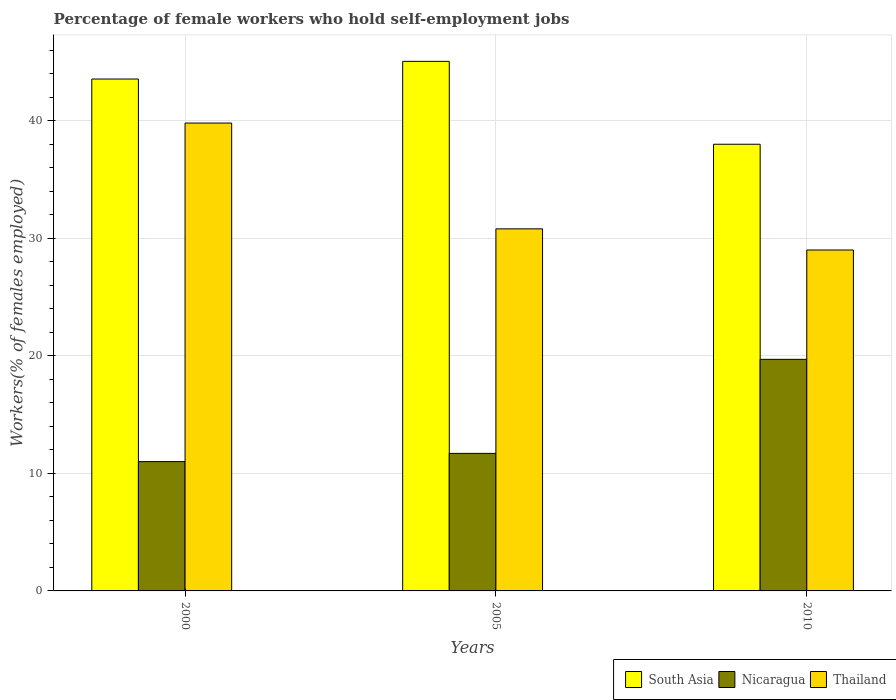How many bars are there on the 1st tick from the left?
Make the answer very short. 3. In how many cases, is the number of bars for a given year not equal to the number of legend labels?
Your answer should be very brief. 0. What is the percentage of self-employed female workers in Nicaragua in 2000?
Provide a succinct answer. 11. Across all years, what is the maximum percentage of self-employed female workers in Nicaragua?
Offer a very short reply. 19.7. Across all years, what is the minimum percentage of self-employed female workers in South Asia?
Provide a succinct answer. 38. In which year was the percentage of self-employed female workers in Nicaragua minimum?
Offer a very short reply. 2000. What is the total percentage of self-employed female workers in Nicaragua in the graph?
Offer a terse response. 42.4. What is the difference between the percentage of self-employed female workers in Nicaragua in 2000 and that in 2010?
Give a very brief answer. -8.7. What is the difference between the percentage of self-employed female workers in Nicaragua in 2010 and the percentage of self-employed female workers in South Asia in 2005?
Offer a very short reply. -25.35. What is the average percentage of self-employed female workers in South Asia per year?
Offer a very short reply. 42.2. In the year 2005, what is the difference between the percentage of self-employed female workers in South Asia and percentage of self-employed female workers in Nicaragua?
Your answer should be compact. 33.35. In how many years, is the percentage of self-employed female workers in Thailand greater than 28 %?
Offer a very short reply. 3. What is the ratio of the percentage of self-employed female workers in Thailand in 2005 to that in 2010?
Ensure brevity in your answer.  1.06. Is the percentage of self-employed female workers in South Asia in 2000 less than that in 2005?
Your answer should be very brief. Yes. What is the difference between the highest and the second highest percentage of self-employed female workers in South Asia?
Keep it short and to the point. 1.5. What is the difference between the highest and the lowest percentage of self-employed female workers in Thailand?
Offer a very short reply. 10.8. In how many years, is the percentage of self-employed female workers in Nicaragua greater than the average percentage of self-employed female workers in Nicaragua taken over all years?
Keep it short and to the point. 1. Is the sum of the percentage of self-employed female workers in Thailand in 2000 and 2010 greater than the maximum percentage of self-employed female workers in South Asia across all years?
Make the answer very short. Yes. What does the 1st bar from the left in 2005 represents?
Ensure brevity in your answer.  South Asia. What does the 3rd bar from the right in 2000 represents?
Your answer should be compact. South Asia. Is it the case that in every year, the sum of the percentage of self-employed female workers in South Asia and percentage of self-employed female workers in Thailand is greater than the percentage of self-employed female workers in Nicaragua?
Make the answer very short. Yes. How many bars are there?
Your answer should be compact. 9. How many years are there in the graph?
Your answer should be very brief. 3. Does the graph contain any zero values?
Keep it short and to the point. No. Where does the legend appear in the graph?
Your answer should be very brief. Bottom right. What is the title of the graph?
Provide a short and direct response. Percentage of female workers who hold self-employment jobs. Does "Sri Lanka" appear as one of the legend labels in the graph?
Make the answer very short. No. What is the label or title of the X-axis?
Keep it short and to the point. Years. What is the label or title of the Y-axis?
Provide a short and direct response. Workers(% of females employed). What is the Workers(% of females employed) in South Asia in 2000?
Offer a very short reply. 43.55. What is the Workers(% of females employed) in Thailand in 2000?
Ensure brevity in your answer.  39.8. What is the Workers(% of females employed) of South Asia in 2005?
Offer a terse response. 45.05. What is the Workers(% of females employed) in Nicaragua in 2005?
Offer a terse response. 11.7. What is the Workers(% of females employed) in Thailand in 2005?
Make the answer very short. 30.8. What is the Workers(% of females employed) of South Asia in 2010?
Your answer should be very brief. 38. What is the Workers(% of females employed) of Nicaragua in 2010?
Offer a very short reply. 19.7. What is the Workers(% of females employed) of Thailand in 2010?
Make the answer very short. 29. Across all years, what is the maximum Workers(% of females employed) of South Asia?
Your answer should be compact. 45.05. Across all years, what is the maximum Workers(% of females employed) of Nicaragua?
Give a very brief answer. 19.7. Across all years, what is the maximum Workers(% of females employed) of Thailand?
Your response must be concise. 39.8. Across all years, what is the minimum Workers(% of females employed) of South Asia?
Your answer should be very brief. 38. What is the total Workers(% of females employed) of South Asia in the graph?
Offer a terse response. 126.59. What is the total Workers(% of females employed) of Nicaragua in the graph?
Your answer should be compact. 42.4. What is the total Workers(% of females employed) of Thailand in the graph?
Your response must be concise. 99.6. What is the difference between the Workers(% of females employed) in South Asia in 2000 and that in 2005?
Your response must be concise. -1.5. What is the difference between the Workers(% of females employed) of Thailand in 2000 and that in 2005?
Offer a very short reply. 9. What is the difference between the Workers(% of females employed) of South Asia in 2000 and that in 2010?
Keep it short and to the point. 5.55. What is the difference between the Workers(% of females employed) of Nicaragua in 2000 and that in 2010?
Provide a short and direct response. -8.7. What is the difference between the Workers(% of females employed) of Thailand in 2000 and that in 2010?
Offer a terse response. 10.8. What is the difference between the Workers(% of females employed) in South Asia in 2005 and that in 2010?
Your response must be concise. 7.05. What is the difference between the Workers(% of females employed) of Nicaragua in 2005 and that in 2010?
Your answer should be very brief. -8. What is the difference between the Workers(% of females employed) in Thailand in 2005 and that in 2010?
Offer a terse response. 1.8. What is the difference between the Workers(% of females employed) of South Asia in 2000 and the Workers(% of females employed) of Nicaragua in 2005?
Your response must be concise. 31.85. What is the difference between the Workers(% of females employed) of South Asia in 2000 and the Workers(% of females employed) of Thailand in 2005?
Ensure brevity in your answer.  12.75. What is the difference between the Workers(% of females employed) in Nicaragua in 2000 and the Workers(% of females employed) in Thailand in 2005?
Make the answer very short. -19.8. What is the difference between the Workers(% of females employed) in South Asia in 2000 and the Workers(% of females employed) in Nicaragua in 2010?
Offer a terse response. 23.85. What is the difference between the Workers(% of females employed) in South Asia in 2000 and the Workers(% of females employed) in Thailand in 2010?
Give a very brief answer. 14.55. What is the difference between the Workers(% of females employed) in South Asia in 2005 and the Workers(% of females employed) in Nicaragua in 2010?
Your answer should be compact. 25.35. What is the difference between the Workers(% of females employed) of South Asia in 2005 and the Workers(% of females employed) of Thailand in 2010?
Your response must be concise. 16.05. What is the difference between the Workers(% of females employed) in Nicaragua in 2005 and the Workers(% of females employed) in Thailand in 2010?
Your answer should be compact. -17.3. What is the average Workers(% of females employed) of South Asia per year?
Your answer should be compact. 42.2. What is the average Workers(% of females employed) in Nicaragua per year?
Your answer should be compact. 14.13. What is the average Workers(% of females employed) of Thailand per year?
Offer a terse response. 33.2. In the year 2000, what is the difference between the Workers(% of females employed) of South Asia and Workers(% of females employed) of Nicaragua?
Give a very brief answer. 32.55. In the year 2000, what is the difference between the Workers(% of females employed) in South Asia and Workers(% of females employed) in Thailand?
Offer a terse response. 3.75. In the year 2000, what is the difference between the Workers(% of females employed) in Nicaragua and Workers(% of females employed) in Thailand?
Your answer should be compact. -28.8. In the year 2005, what is the difference between the Workers(% of females employed) of South Asia and Workers(% of females employed) of Nicaragua?
Your response must be concise. 33.35. In the year 2005, what is the difference between the Workers(% of females employed) in South Asia and Workers(% of females employed) in Thailand?
Offer a very short reply. 14.25. In the year 2005, what is the difference between the Workers(% of females employed) in Nicaragua and Workers(% of females employed) in Thailand?
Offer a very short reply. -19.1. In the year 2010, what is the difference between the Workers(% of females employed) in South Asia and Workers(% of females employed) in Nicaragua?
Ensure brevity in your answer.  18.3. In the year 2010, what is the difference between the Workers(% of females employed) in South Asia and Workers(% of females employed) in Thailand?
Provide a short and direct response. 9. What is the ratio of the Workers(% of females employed) in South Asia in 2000 to that in 2005?
Offer a terse response. 0.97. What is the ratio of the Workers(% of females employed) of Nicaragua in 2000 to that in 2005?
Offer a very short reply. 0.94. What is the ratio of the Workers(% of females employed) in Thailand in 2000 to that in 2005?
Give a very brief answer. 1.29. What is the ratio of the Workers(% of females employed) of South Asia in 2000 to that in 2010?
Keep it short and to the point. 1.15. What is the ratio of the Workers(% of females employed) in Nicaragua in 2000 to that in 2010?
Provide a succinct answer. 0.56. What is the ratio of the Workers(% of females employed) of Thailand in 2000 to that in 2010?
Your answer should be compact. 1.37. What is the ratio of the Workers(% of females employed) of South Asia in 2005 to that in 2010?
Make the answer very short. 1.19. What is the ratio of the Workers(% of females employed) in Nicaragua in 2005 to that in 2010?
Your answer should be very brief. 0.59. What is the ratio of the Workers(% of females employed) in Thailand in 2005 to that in 2010?
Your answer should be compact. 1.06. What is the difference between the highest and the second highest Workers(% of females employed) of South Asia?
Provide a succinct answer. 1.5. What is the difference between the highest and the second highest Workers(% of females employed) in Nicaragua?
Your answer should be very brief. 8. What is the difference between the highest and the lowest Workers(% of females employed) in South Asia?
Make the answer very short. 7.05. What is the difference between the highest and the lowest Workers(% of females employed) in Nicaragua?
Your answer should be compact. 8.7. What is the difference between the highest and the lowest Workers(% of females employed) in Thailand?
Keep it short and to the point. 10.8. 